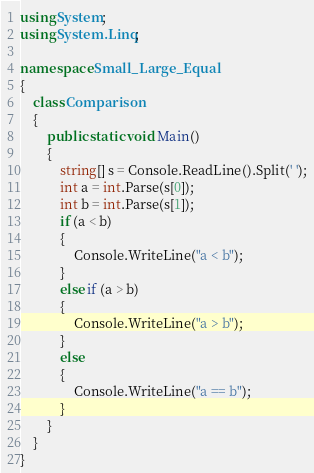Convert code to text. <code><loc_0><loc_0><loc_500><loc_500><_C#_>using System;
using System.Linq;

namespace Small_Large_Equal
{
    class Comparison
    {
        public static void Main()
        {
            string[] s = Console.ReadLine().Split(' ');
            int a = int.Parse(s[0]);
            int b = int.Parse(s[1]);
            if (a < b)
            {
                Console.WriteLine("a < b");
            }
            else if (a > b)
            {
                Console.WriteLine("a > b");
            }
            else
            {
                Console.WriteLine("a == b");
            }
        }
    }
}

</code> 